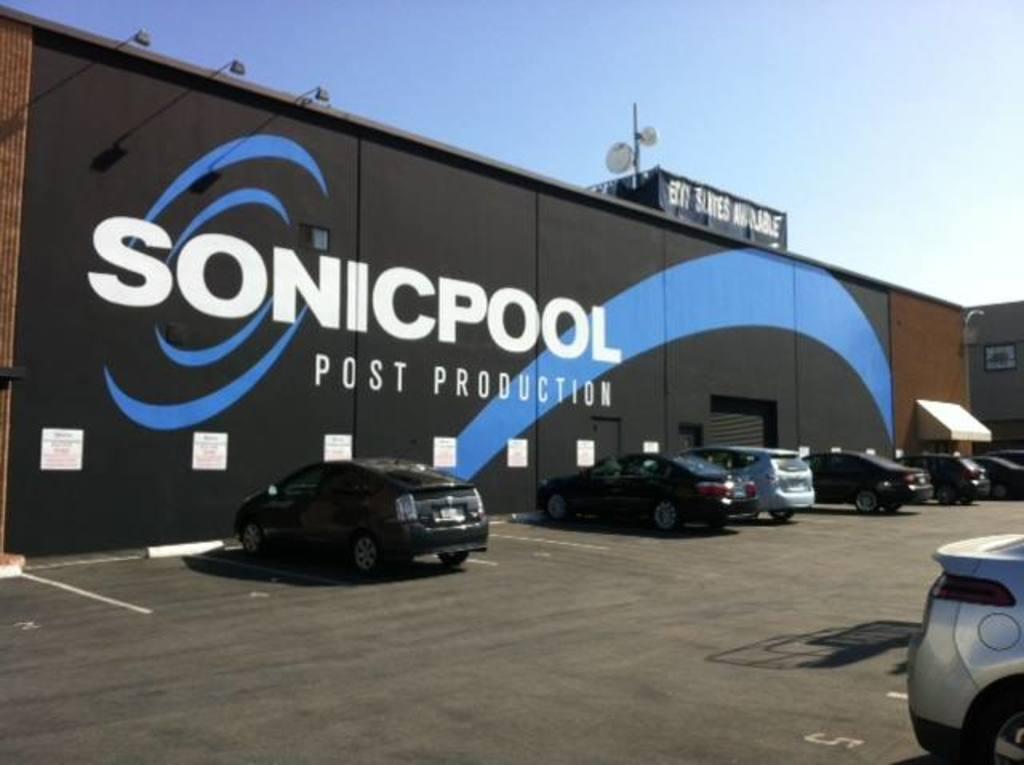How would you summarize this image in a sentence or two? In this image in the front there are cars. In the background there is a wall and on the wall there is some text written on it. On the top of the wall there is a banner with some text and there is an antenna and there are lights on the wall which are hanging. 